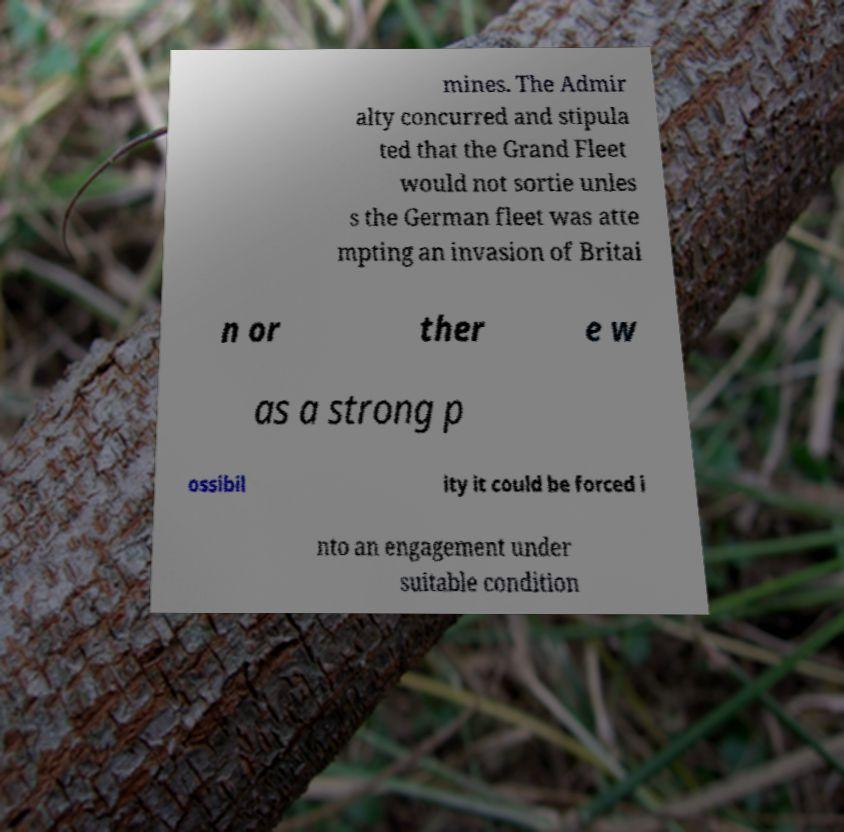For documentation purposes, I need the text within this image transcribed. Could you provide that? mines. The Admir alty concurred and stipula ted that the Grand Fleet would not sortie unles s the German fleet was atte mpting an invasion of Britai n or ther e w as a strong p ossibil ity it could be forced i nto an engagement under suitable condition 